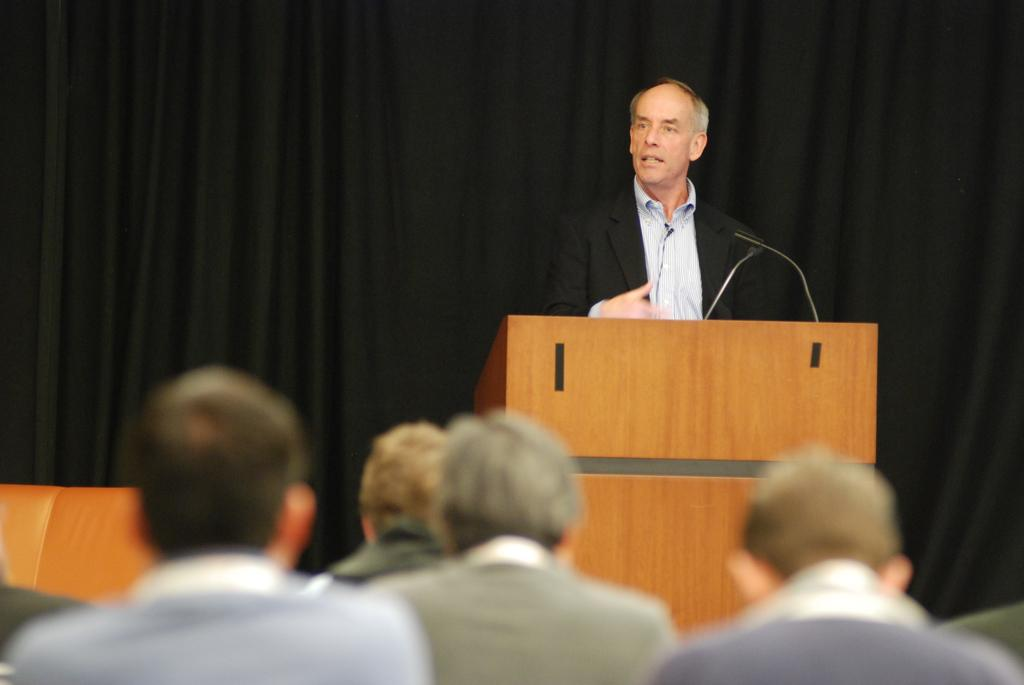How many people are in the image? There is a group of people in the image. What are the people in the image doing? The people are sitting towards a podium. Who is speaking to the group? A man is addressing the gathering. What can be seen behind the people in the image? There is a black curtain in the image. What type of joke is the man telling during the competition in the image? There is no competition or joke present in the image; it features a group of people sitting towards a podium while a man addresses the gathering. 